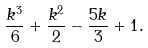<formula> <loc_0><loc_0><loc_500><loc_500>\frac { k ^ { 3 } } { 6 } + \frac { k ^ { 2 } } { 2 } - \frac { 5 k } { 3 } + 1 .</formula> 